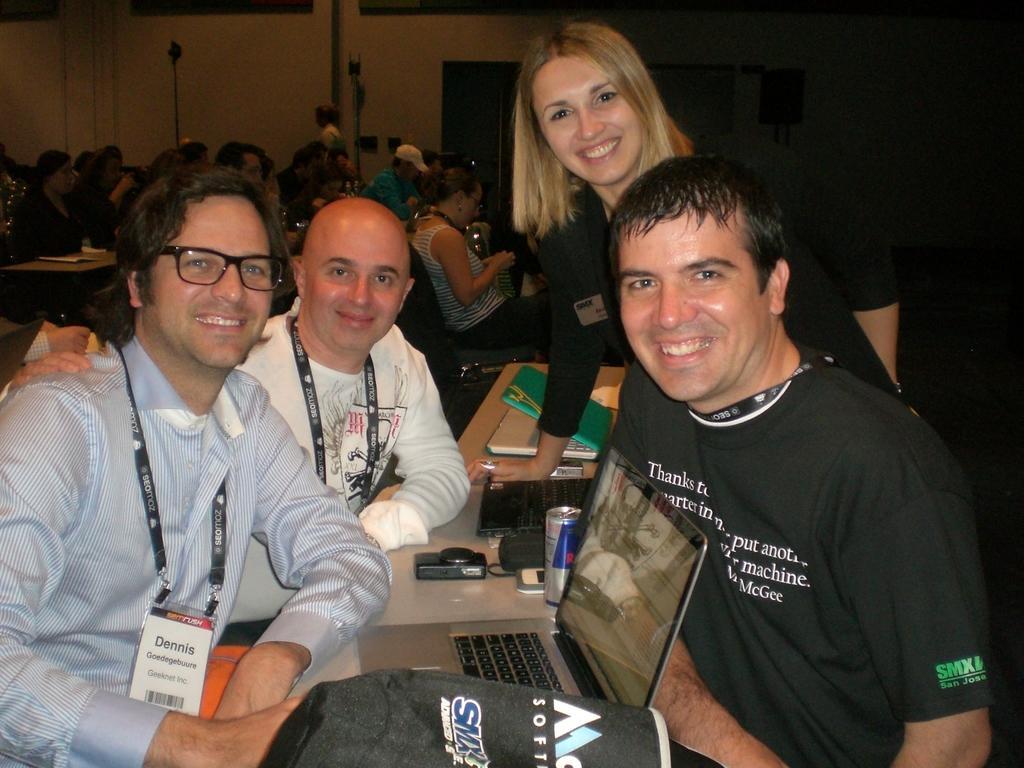How would you summarize this image in a sentence or two? In this picture there are people those who are sitting on the right and left side of the image and there is a table in the center of the image, which contains laptops on it, there are other people in the background area of the image. 